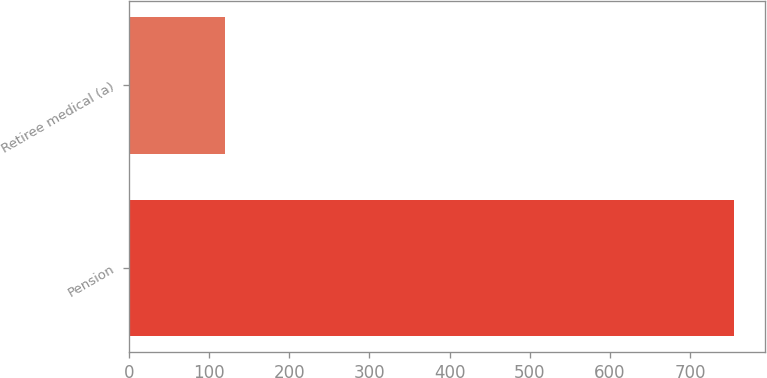Convert chart to OTSL. <chart><loc_0><loc_0><loc_500><loc_500><bar_chart><fcel>Pension<fcel>Retiree medical (a)<nl><fcel>755<fcel>120<nl></chart> 